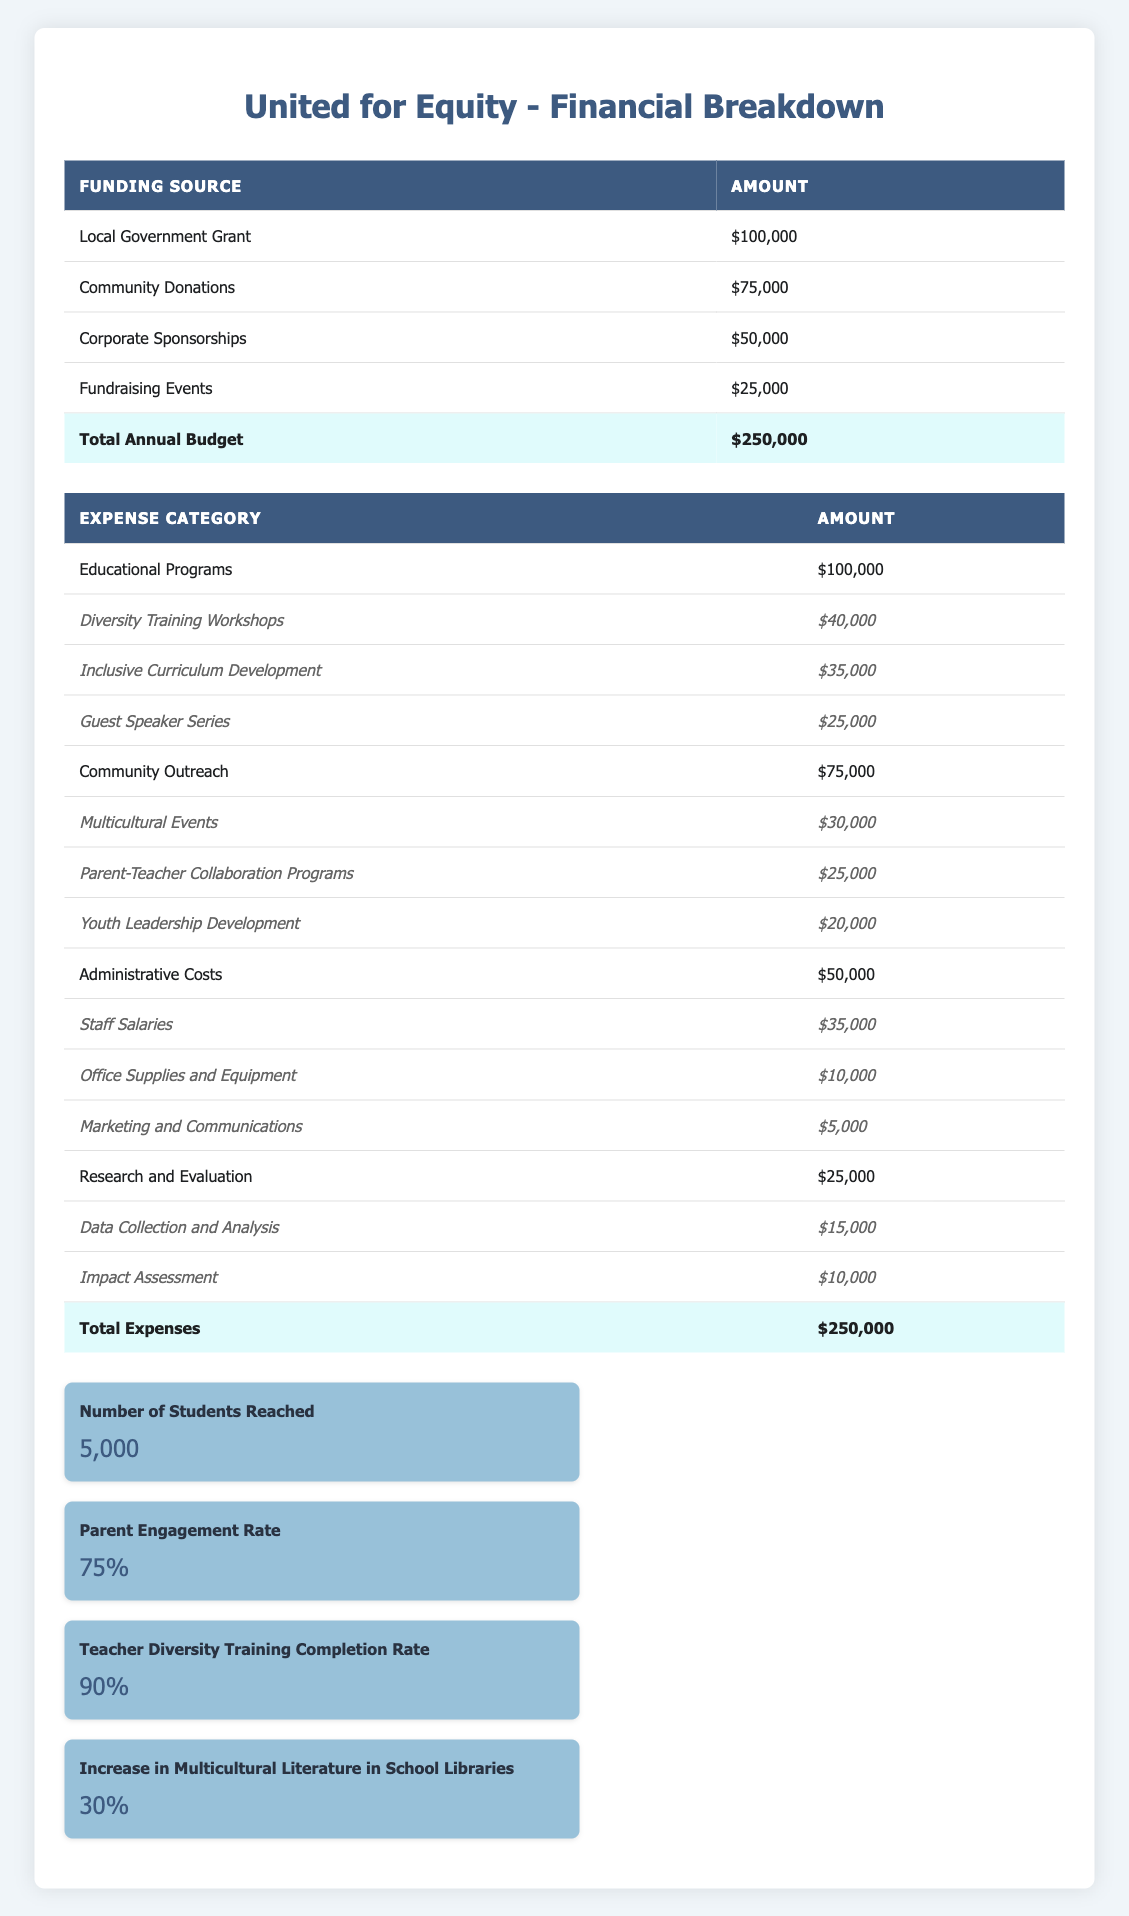What is the total amount funded by the Local Government Grant? The table shows that the amount funded by the Local Government Grant is $100,000.
Answer: $100,000 How much was allocated to Educational Programs? According to the table, the total amount allocated to Educational Programs is $100,000.
Answer: $100,000 What is the expense category with the highest funding? By examining the table, Educational Programs received the highest funding of $100,000 compared to other categories.
Answer: Educational Programs What is the total amount spent on Community Outreach? The table indicates that Community Outreach has a total expense of $75,000.
Answer: $75,000 What was the amount spent on Diversity Training Workshops? The specific amount spent on Diversity Training Workshops is $40,000 as indicated in the table.
Answer: $40,000 Is the Parent Engagement Rate above 70%? According to the data, the Parent Engagement Rate is 75%, which is above 70%.
Answer: Yes What percentage of the total budget is allocated to Administrative Costs? The total annual budget is $250,000, and the Administrative Costs are $50,000. To find the percentage allocated, the calculation is (50,000 / 250,000) * 100 = 20%.
Answer: 20% Which funding source contributed the least amount? The table indicates that Fundraising Events contributed the least amount of $25,000 when comparing all funding sources.
Answer: Fundraising Events What is the combined amount for Multicultural Events and Youth Leadership Development? The amount for Multicultural Events is $30,000 and for Youth Leadership Development is $20,000. The combined amount is 30,000 + 20,000 = 50,000.
Answer: $50,000 How many key performance indicators indicate a success rate of 80% or higher? The table lists four key performance indicators, and out of these, the Teacher Diversity Training Completion Rate is 90%, which is above 80%. Thus, there is 1 KPI indicating a success rate of 80% or higher.
Answer: 1 